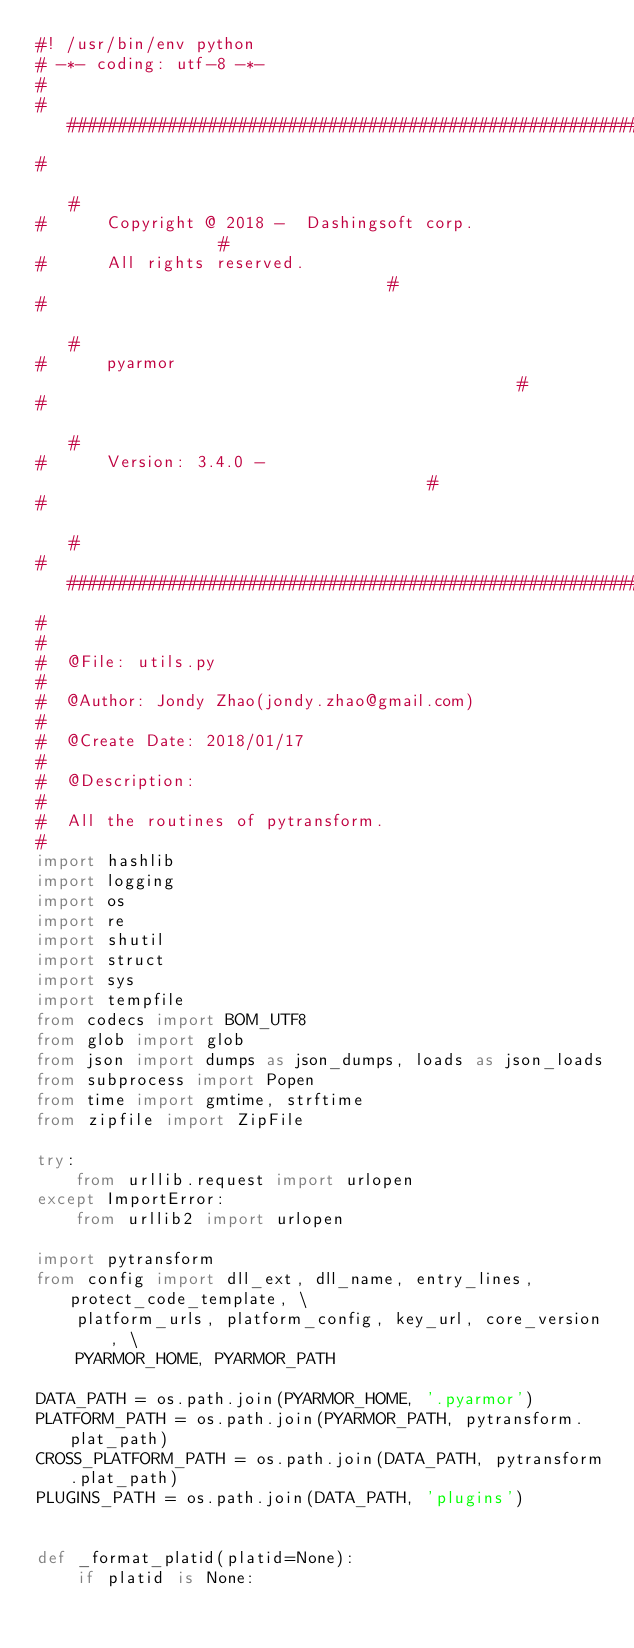<code> <loc_0><loc_0><loc_500><loc_500><_Python_>#! /usr/bin/env python
# -*- coding: utf-8 -*-
#
#############################################################
#                                                           #
#      Copyright @ 2018 -  Dashingsoft corp.                #
#      All rights reserved.                                 #
#                                                           #
#      pyarmor                                              #
#                                                           #
#      Version: 3.4.0 -                                     #
#                                                           #
#############################################################
#
#
#  @File: utils.py
#
#  @Author: Jondy Zhao(jondy.zhao@gmail.com)
#
#  @Create Date: 2018/01/17
#
#  @Description:
#
#  All the routines of pytransform.
#
import hashlib
import logging
import os
import re
import shutil
import struct
import sys
import tempfile
from codecs import BOM_UTF8
from glob import glob
from json import dumps as json_dumps, loads as json_loads
from subprocess import Popen
from time import gmtime, strftime
from zipfile import ZipFile

try:
    from urllib.request import urlopen
except ImportError:
    from urllib2 import urlopen

import pytransform
from config import dll_ext, dll_name, entry_lines, protect_code_template, \
    platform_urls, platform_config, key_url, core_version, \
    PYARMOR_HOME, PYARMOR_PATH

DATA_PATH = os.path.join(PYARMOR_HOME, '.pyarmor')
PLATFORM_PATH = os.path.join(PYARMOR_PATH, pytransform.plat_path)
CROSS_PLATFORM_PATH = os.path.join(DATA_PATH, pytransform.plat_path)
PLUGINS_PATH = os.path.join(DATA_PATH, 'plugins')


def _format_platid(platid=None):
    if platid is None:</code> 